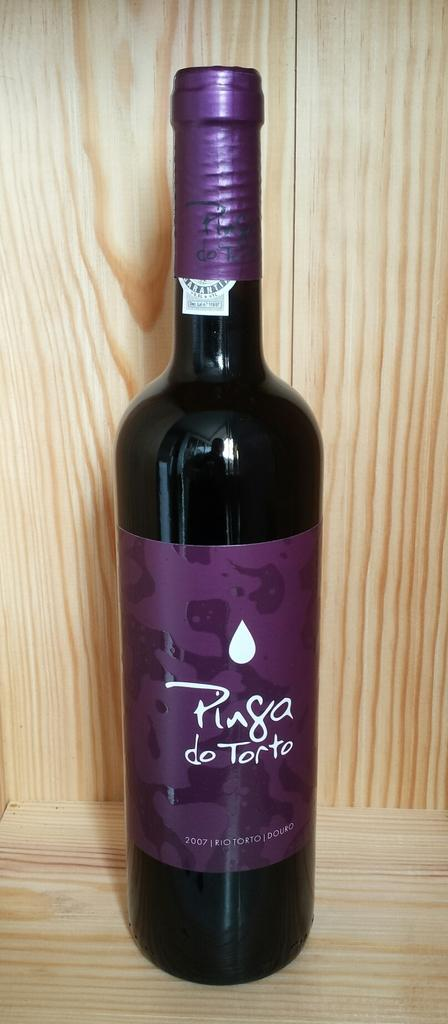<image>
Offer a succinct explanation of the picture presented. A purple bottle has the year 2007 on it. 